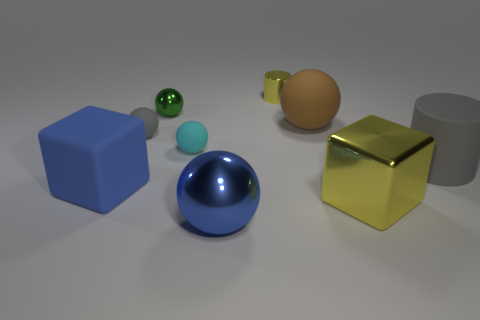Can you describe the different materials and textures apparent in the objects shown? Certainly! The image presents a diverse array of objects that showcase a variety of materials and textures. The blue cube on the left exhibits a matte texture, suggesting a plastic or painted surface. The big gray cylinder to its right also features a matte surface with a neutral hue, possibly made of metal or ceramic. Next, there's a small blue sphere with a shiny rubber texture, indicative of a bouncy ball or similar material. The small green sphere also seems to have a similar rubber texture. In contrast, the golden cube in the center has a reflective and polished surface which could be made of metal or a gold-colored plastic with a metallic finish. The brown object, shaped like an egg, presents a smooth, opaque surface that seems like it could be ceramic. Lastly, we have the large, glossy blue sphere, which has reflective attributes that suggest it could be made of glass or a highly polished stone. 